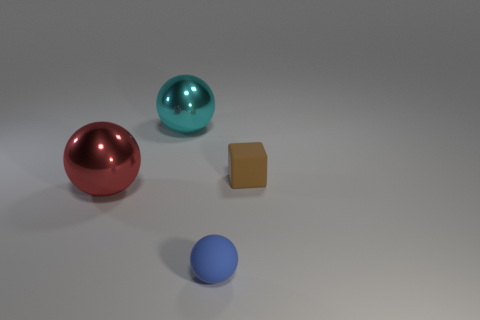Add 2 small objects. How many objects exist? 6 Subtract all large red spheres. How many spheres are left? 2 Subtract all balls. How many objects are left? 1 Subtract all cyan balls. How many balls are left? 2 Subtract all small green shiny cylinders. Subtract all small things. How many objects are left? 2 Add 2 large red objects. How many large red objects are left? 3 Add 2 tiny brown rubber things. How many tiny brown rubber things exist? 3 Subtract 0 red blocks. How many objects are left? 4 Subtract all red spheres. Subtract all cyan cylinders. How many spheres are left? 2 